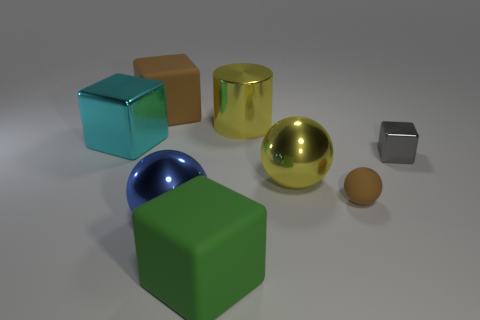Subtract all big metal cubes. How many cubes are left? 3 Add 1 shiny objects. How many objects exist? 9 Subtract all brown spheres. How many spheres are left? 2 Add 1 cyan things. How many cyan things exist? 2 Subtract 1 yellow cylinders. How many objects are left? 7 Subtract all balls. How many objects are left? 5 Subtract 3 cubes. How many cubes are left? 1 Subtract all cyan balls. Subtract all gray blocks. How many balls are left? 3 Subtract all blue cylinders. How many green balls are left? 0 Subtract all tiny matte objects. Subtract all green matte objects. How many objects are left? 6 